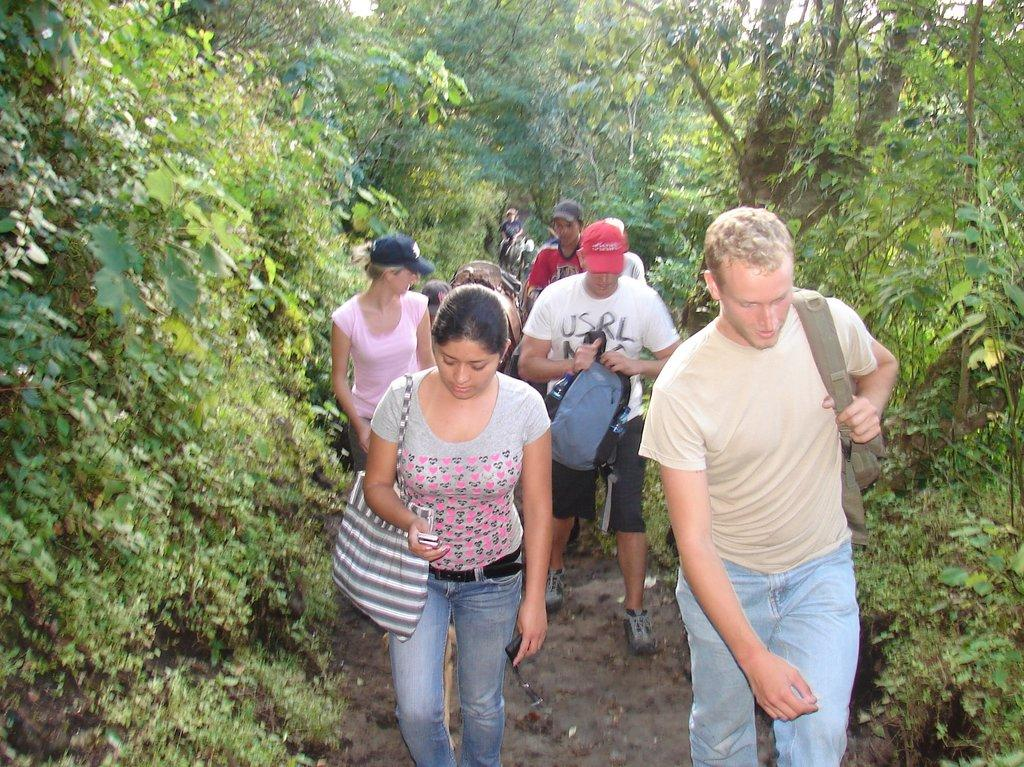What is happening in the image involving a group of people? There is a group of people in the image, and they are carrying bags. What is the ground like in the image? The people are walking on the ground in the image. Can you describe the attire of some of the people in the image? Some of the people in the image are wearing caps. What can be seen in the background of the image? There are trees visible in the background of the image. What type of ink is being used by the people in the image? There is no ink present in the image; the people are carrying bags and walking on the ground. What is the purpose of the toothbrush in the image? There is no toothbrush present in the image. 